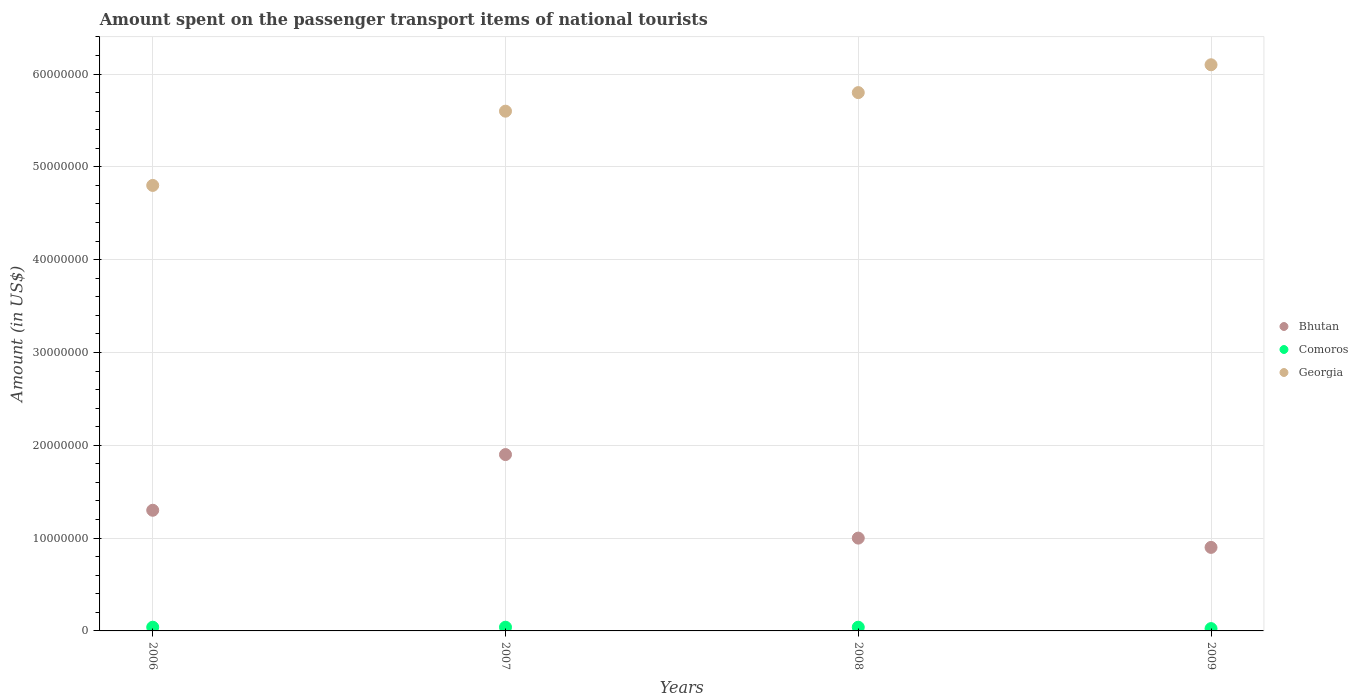Is the number of dotlines equal to the number of legend labels?
Provide a short and direct response. Yes. What is the amount spent on the passenger transport items of national tourists in Bhutan in 2009?
Keep it short and to the point. 9.00e+06. Across all years, what is the maximum amount spent on the passenger transport items of national tourists in Comoros?
Offer a terse response. 4.00e+05. In which year was the amount spent on the passenger transport items of national tourists in Comoros maximum?
Give a very brief answer. 2006. In which year was the amount spent on the passenger transport items of national tourists in Comoros minimum?
Your answer should be compact. 2009. What is the total amount spent on the passenger transport items of national tourists in Georgia in the graph?
Provide a short and direct response. 2.23e+08. What is the difference between the amount spent on the passenger transport items of national tourists in Georgia in 2007 and that in 2008?
Keep it short and to the point. -2.00e+06. What is the difference between the amount spent on the passenger transport items of national tourists in Comoros in 2008 and the amount spent on the passenger transport items of national tourists in Georgia in 2009?
Offer a terse response. -6.06e+07. What is the average amount spent on the passenger transport items of national tourists in Bhutan per year?
Give a very brief answer. 1.28e+07. In the year 2008, what is the difference between the amount spent on the passenger transport items of national tourists in Georgia and amount spent on the passenger transport items of national tourists in Comoros?
Your response must be concise. 5.76e+07. Is the amount spent on the passenger transport items of national tourists in Comoros in 2006 less than that in 2009?
Your answer should be very brief. No. Is the difference between the amount spent on the passenger transport items of national tourists in Georgia in 2007 and 2008 greater than the difference between the amount spent on the passenger transport items of national tourists in Comoros in 2007 and 2008?
Your response must be concise. No. What is the difference between the highest and the second highest amount spent on the passenger transport items of national tourists in Georgia?
Make the answer very short. 3.00e+06. What is the difference between the highest and the lowest amount spent on the passenger transport items of national tourists in Georgia?
Make the answer very short. 1.30e+07. In how many years, is the amount spent on the passenger transport items of national tourists in Georgia greater than the average amount spent on the passenger transport items of national tourists in Georgia taken over all years?
Ensure brevity in your answer.  3. Does the amount spent on the passenger transport items of national tourists in Comoros monotonically increase over the years?
Provide a succinct answer. No. Is the amount spent on the passenger transport items of national tourists in Comoros strictly less than the amount spent on the passenger transport items of national tourists in Georgia over the years?
Give a very brief answer. Yes. How many dotlines are there?
Keep it short and to the point. 3. Does the graph contain any zero values?
Offer a very short reply. No. How many legend labels are there?
Your answer should be very brief. 3. What is the title of the graph?
Offer a very short reply. Amount spent on the passenger transport items of national tourists. Does "Sub-Saharan Africa (all income levels)" appear as one of the legend labels in the graph?
Provide a succinct answer. No. What is the label or title of the X-axis?
Make the answer very short. Years. What is the Amount (in US$) in Bhutan in 2006?
Your answer should be very brief. 1.30e+07. What is the Amount (in US$) of Georgia in 2006?
Keep it short and to the point. 4.80e+07. What is the Amount (in US$) of Bhutan in 2007?
Your answer should be compact. 1.90e+07. What is the Amount (in US$) in Georgia in 2007?
Give a very brief answer. 5.60e+07. What is the Amount (in US$) of Bhutan in 2008?
Offer a terse response. 1.00e+07. What is the Amount (in US$) of Georgia in 2008?
Your answer should be compact. 5.80e+07. What is the Amount (in US$) of Bhutan in 2009?
Keep it short and to the point. 9.00e+06. What is the Amount (in US$) in Georgia in 2009?
Offer a very short reply. 6.10e+07. Across all years, what is the maximum Amount (in US$) in Bhutan?
Your answer should be compact. 1.90e+07. Across all years, what is the maximum Amount (in US$) of Georgia?
Your response must be concise. 6.10e+07. Across all years, what is the minimum Amount (in US$) in Bhutan?
Provide a short and direct response. 9.00e+06. Across all years, what is the minimum Amount (in US$) of Georgia?
Your answer should be very brief. 4.80e+07. What is the total Amount (in US$) in Bhutan in the graph?
Provide a short and direct response. 5.10e+07. What is the total Amount (in US$) in Comoros in the graph?
Provide a short and direct response. 1.45e+06. What is the total Amount (in US$) of Georgia in the graph?
Your response must be concise. 2.23e+08. What is the difference between the Amount (in US$) of Bhutan in 2006 and that in 2007?
Offer a very short reply. -6.00e+06. What is the difference between the Amount (in US$) in Georgia in 2006 and that in 2007?
Your response must be concise. -8.00e+06. What is the difference between the Amount (in US$) of Comoros in 2006 and that in 2008?
Make the answer very short. 0. What is the difference between the Amount (in US$) of Georgia in 2006 and that in 2008?
Provide a short and direct response. -1.00e+07. What is the difference between the Amount (in US$) in Bhutan in 2006 and that in 2009?
Your answer should be very brief. 4.00e+06. What is the difference between the Amount (in US$) in Georgia in 2006 and that in 2009?
Provide a succinct answer. -1.30e+07. What is the difference between the Amount (in US$) in Bhutan in 2007 and that in 2008?
Your answer should be very brief. 9.00e+06. What is the difference between the Amount (in US$) in Georgia in 2007 and that in 2008?
Ensure brevity in your answer.  -2.00e+06. What is the difference between the Amount (in US$) in Bhutan in 2007 and that in 2009?
Ensure brevity in your answer.  1.00e+07. What is the difference between the Amount (in US$) in Comoros in 2007 and that in 2009?
Your answer should be very brief. 1.50e+05. What is the difference between the Amount (in US$) of Georgia in 2007 and that in 2009?
Provide a succinct answer. -5.00e+06. What is the difference between the Amount (in US$) of Bhutan in 2008 and that in 2009?
Your response must be concise. 1.00e+06. What is the difference between the Amount (in US$) in Comoros in 2008 and that in 2009?
Make the answer very short. 1.50e+05. What is the difference between the Amount (in US$) in Bhutan in 2006 and the Amount (in US$) in Comoros in 2007?
Make the answer very short. 1.26e+07. What is the difference between the Amount (in US$) of Bhutan in 2006 and the Amount (in US$) of Georgia in 2007?
Your answer should be very brief. -4.30e+07. What is the difference between the Amount (in US$) in Comoros in 2006 and the Amount (in US$) in Georgia in 2007?
Offer a very short reply. -5.56e+07. What is the difference between the Amount (in US$) in Bhutan in 2006 and the Amount (in US$) in Comoros in 2008?
Ensure brevity in your answer.  1.26e+07. What is the difference between the Amount (in US$) in Bhutan in 2006 and the Amount (in US$) in Georgia in 2008?
Ensure brevity in your answer.  -4.50e+07. What is the difference between the Amount (in US$) in Comoros in 2006 and the Amount (in US$) in Georgia in 2008?
Give a very brief answer. -5.76e+07. What is the difference between the Amount (in US$) in Bhutan in 2006 and the Amount (in US$) in Comoros in 2009?
Keep it short and to the point. 1.28e+07. What is the difference between the Amount (in US$) in Bhutan in 2006 and the Amount (in US$) in Georgia in 2009?
Make the answer very short. -4.80e+07. What is the difference between the Amount (in US$) of Comoros in 2006 and the Amount (in US$) of Georgia in 2009?
Provide a short and direct response. -6.06e+07. What is the difference between the Amount (in US$) of Bhutan in 2007 and the Amount (in US$) of Comoros in 2008?
Ensure brevity in your answer.  1.86e+07. What is the difference between the Amount (in US$) of Bhutan in 2007 and the Amount (in US$) of Georgia in 2008?
Keep it short and to the point. -3.90e+07. What is the difference between the Amount (in US$) in Comoros in 2007 and the Amount (in US$) in Georgia in 2008?
Your answer should be very brief. -5.76e+07. What is the difference between the Amount (in US$) of Bhutan in 2007 and the Amount (in US$) of Comoros in 2009?
Make the answer very short. 1.88e+07. What is the difference between the Amount (in US$) in Bhutan in 2007 and the Amount (in US$) in Georgia in 2009?
Provide a succinct answer. -4.20e+07. What is the difference between the Amount (in US$) in Comoros in 2007 and the Amount (in US$) in Georgia in 2009?
Your response must be concise. -6.06e+07. What is the difference between the Amount (in US$) of Bhutan in 2008 and the Amount (in US$) of Comoros in 2009?
Offer a very short reply. 9.75e+06. What is the difference between the Amount (in US$) in Bhutan in 2008 and the Amount (in US$) in Georgia in 2009?
Your answer should be compact. -5.10e+07. What is the difference between the Amount (in US$) of Comoros in 2008 and the Amount (in US$) of Georgia in 2009?
Give a very brief answer. -6.06e+07. What is the average Amount (in US$) of Bhutan per year?
Keep it short and to the point. 1.28e+07. What is the average Amount (in US$) in Comoros per year?
Your answer should be very brief. 3.62e+05. What is the average Amount (in US$) in Georgia per year?
Offer a terse response. 5.58e+07. In the year 2006, what is the difference between the Amount (in US$) of Bhutan and Amount (in US$) of Comoros?
Offer a very short reply. 1.26e+07. In the year 2006, what is the difference between the Amount (in US$) of Bhutan and Amount (in US$) of Georgia?
Offer a very short reply. -3.50e+07. In the year 2006, what is the difference between the Amount (in US$) in Comoros and Amount (in US$) in Georgia?
Offer a very short reply. -4.76e+07. In the year 2007, what is the difference between the Amount (in US$) of Bhutan and Amount (in US$) of Comoros?
Ensure brevity in your answer.  1.86e+07. In the year 2007, what is the difference between the Amount (in US$) of Bhutan and Amount (in US$) of Georgia?
Make the answer very short. -3.70e+07. In the year 2007, what is the difference between the Amount (in US$) of Comoros and Amount (in US$) of Georgia?
Your answer should be compact. -5.56e+07. In the year 2008, what is the difference between the Amount (in US$) of Bhutan and Amount (in US$) of Comoros?
Ensure brevity in your answer.  9.60e+06. In the year 2008, what is the difference between the Amount (in US$) in Bhutan and Amount (in US$) in Georgia?
Give a very brief answer. -4.80e+07. In the year 2008, what is the difference between the Amount (in US$) in Comoros and Amount (in US$) in Georgia?
Keep it short and to the point. -5.76e+07. In the year 2009, what is the difference between the Amount (in US$) of Bhutan and Amount (in US$) of Comoros?
Your response must be concise. 8.75e+06. In the year 2009, what is the difference between the Amount (in US$) of Bhutan and Amount (in US$) of Georgia?
Provide a short and direct response. -5.20e+07. In the year 2009, what is the difference between the Amount (in US$) of Comoros and Amount (in US$) of Georgia?
Your answer should be compact. -6.08e+07. What is the ratio of the Amount (in US$) in Bhutan in 2006 to that in 2007?
Give a very brief answer. 0.68. What is the ratio of the Amount (in US$) in Comoros in 2006 to that in 2007?
Make the answer very short. 1. What is the ratio of the Amount (in US$) of Georgia in 2006 to that in 2007?
Make the answer very short. 0.86. What is the ratio of the Amount (in US$) in Bhutan in 2006 to that in 2008?
Give a very brief answer. 1.3. What is the ratio of the Amount (in US$) of Comoros in 2006 to that in 2008?
Ensure brevity in your answer.  1. What is the ratio of the Amount (in US$) of Georgia in 2006 to that in 2008?
Make the answer very short. 0.83. What is the ratio of the Amount (in US$) in Bhutan in 2006 to that in 2009?
Offer a terse response. 1.44. What is the ratio of the Amount (in US$) of Comoros in 2006 to that in 2009?
Offer a very short reply. 1.6. What is the ratio of the Amount (in US$) of Georgia in 2006 to that in 2009?
Give a very brief answer. 0.79. What is the ratio of the Amount (in US$) of Bhutan in 2007 to that in 2008?
Your answer should be very brief. 1.9. What is the ratio of the Amount (in US$) in Comoros in 2007 to that in 2008?
Give a very brief answer. 1. What is the ratio of the Amount (in US$) in Georgia in 2007 to that in 2008?
Make the answer very short. 0.97. What is the ratio of the Amount (in US$) in Bhutan in 2007 to that in 2009?
Offer a terse response. 2.11. What is the ratio of the Amount (in US$) in Comoros in 2007 to that in 2009?
Make the answer very short. 1.6. What is the ratio of the Amount (in US$) of Georgia in 2007 to that in 2009?
Keep it short and to the point. 0.92. What is the ratio of the Amount (in US$) in Georgia in 2008 to that in 2009?
Make the answer very short. 0.95. What is the difference between the highest and the lowest Amount (in US$) in Comoros?
Your answer should be compact. 1.50e+05. What is the difference between the highest and the lowest Amount (in US$) of Georgia?
Your answer should be very brief. 1.30e+07. 